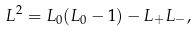Convert formula to latex. <formula><loc_0><loc_0><loc_500><loc_500>L ^ { 2 } = L _ { 0 } ( L _ { 0 } - 1 ) - L _ { + } L _ { - } ,</formula> 